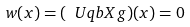Convert formula to latex. <formula><loc_0><loc_0><loc_500><loc_500>w ( x ) = ( \ U q b X g ) ( x ) = 0</formula> 